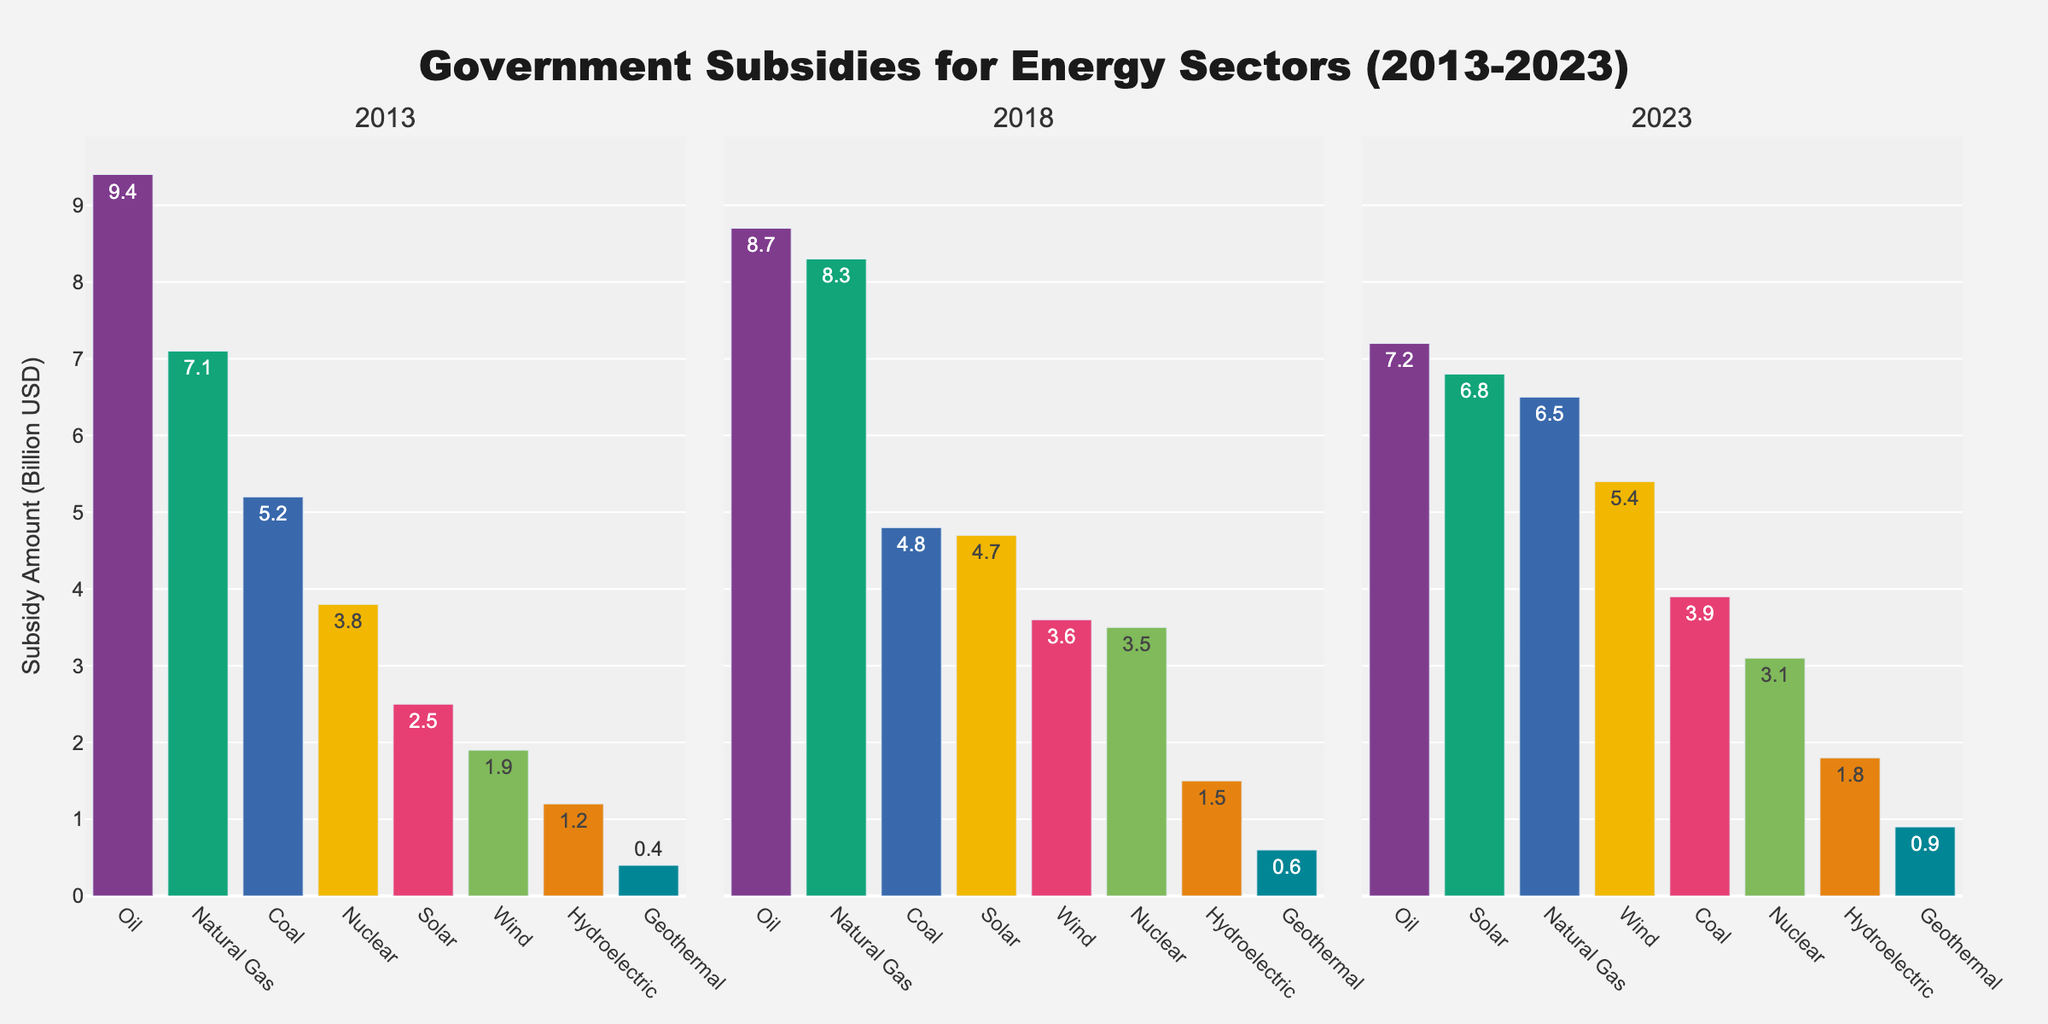How has the subsidy for coal changed from 2013 to 2023? First, identify the subsidy amount for coal in 2013 and 2023 from the figure. In 2013, the subsidy was 5.2 billion USD, and in 2023, it was 3.9 billion USD. Calculate the difference to find the change: 5.2 - 3.9 = 1.3 billion USD.
Answer: It decreased by 1.3 billion USD Which energy sector received the highest subsidy in 2023? Look at the bars for 2023 and identify the sector with the tallest bar. This represents the highest subsidy amount. In 2023, Natural Gas received the highest subsidy of 6.5 billion USD.
Answer: Natural Gas Compare the subsidies for solar energy in 2013 and 2023. What is the percentage increase? Identify the subsidy amounts for solar energy in 2013 and 2023: 2013 is 2.5 billion USD and 2023 is 6.8 billion USD. Calculate the difference: 6.8 - 2.5 = 4.3 billion USD. Find the percentage increase: (4.3 / 2.5) * 100 = 172%.
Answer: 172% Which energy sector shows the largest absolute increase in subsidies from 2013 to 2023? Calculate the absolute differences for each sector from 2013 to 2023: Coal (5.2 - 3.9 = 1.3), Natural Gas (7.1 - 6.5 = 0.6), Oil (9.4 - 7.2 = 2.2), Nuclear (3.8 - 3.1 = 0.7), Solar (6.8 - 2.5 = 4.3), Wind (5.4 - 1.9 = 3.5), Hydroelectric (1.8 - 1.2 = 0.6), Geothermal (0.9 - 0.4 = 0.5). Solar shows the largest increase of 4.3 billion USD.
Answer: Solar In 2018, which two sectors had almost equal subsidy amounts and what were they? Look at the bars for 2018. Identify sectors with nearly the same bar heights. Natural Gas (8.3 billion USD) and Oil (8.7 billion USD) are closest.
Answer: Natural Gas and Oil What is the total subsidy amount for renewable energy sectors (Solar, Wind, Hydroelectric, Geothermal) in 2023? Sum the subsidy amounts for Solar, Wind, Hydroelectric, and Geothermal in 2023: 6.8 (Solar) + 5.4 (Wind) + 1.8 (Hydroelectric) + 0.9 (Geothermal) = 14.9 billion USD.
Answer: 14.9 billion USD Which energy sector shows a consistent decrease in subsidies over the three years (2013, 2018, 2023)? Observe the trends for each sector across 2013, 2018, and 2023. Sectors that decrease over all three years are Coal (5.2, 4.8, 3.9), Oil (9.4, 8.7, 7.2), and Nuclear (3.8, 3.5, 3.1).
Answer: Coal, Oil, and Nuclear 